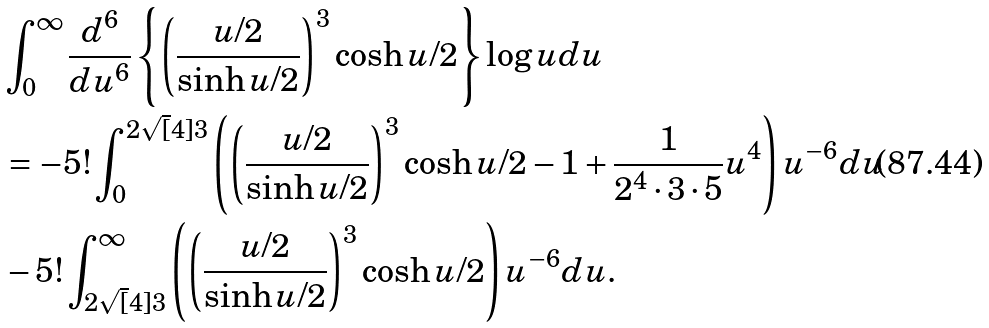Convert formula to latex. <formula><loc_0><loc_0><loc_500><loc_500>& \int _ { 0 } ^ { \infty } \frac { d ^ { 6 } } { d u ^ { 6 } } \left \{ \left ( \frac { u / 2 } { \sinh u / 2 } \right ) ^ { 3 } \cosh u / 2 \right \} \log u d u \\ & = - 5 ! \int _ { 0 } ^ { 2 { \sqrt { [ } 4 ] { 3 } } } \left ( \left ( \frac { u / 2 } { \sinh u / 2 } \right ) ^ { 3 } \cosh u / 2 - 1 + \frac { 1 } { 2 ^ { 4 } \cdot 3 \cdot 5 } u ^ { 4 } \right ) u ^ { - 6 } d u \\ & - 5 ! \int _ { 2 { \sqrt { [ } 4 ] { 3 } } } ^ { \infty } \left ( \left ( \frac { u / 2 } { \sinh u / 2 } \right ) ^ { 3 } \cosh u / 2 \right ) u ^ { - 6 } d u .</formula> 